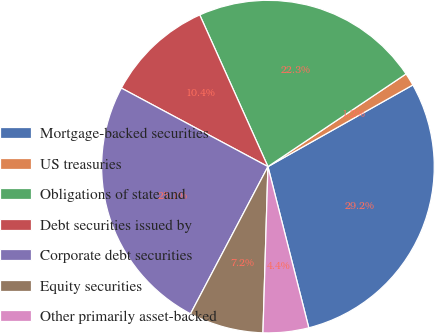Convert chart. <chart><loc_0><loc_0><loc_500><loc_500><pie_chart><fcel>Mortgage-backed securities<fcel>US treasuries<fcel>Obligations of state and<fcel>Debt securities issued by<fcel>Corporate debt securities<fcel>Equity securities<fcel>Other primarily asset-backed<nl><fcel>29.22%<fcel>1.24%<fcel>22.32%<fcel>10.45%<fcel>25.12%<fcel>7.23%<fcel>4.43%<nl></chart> 